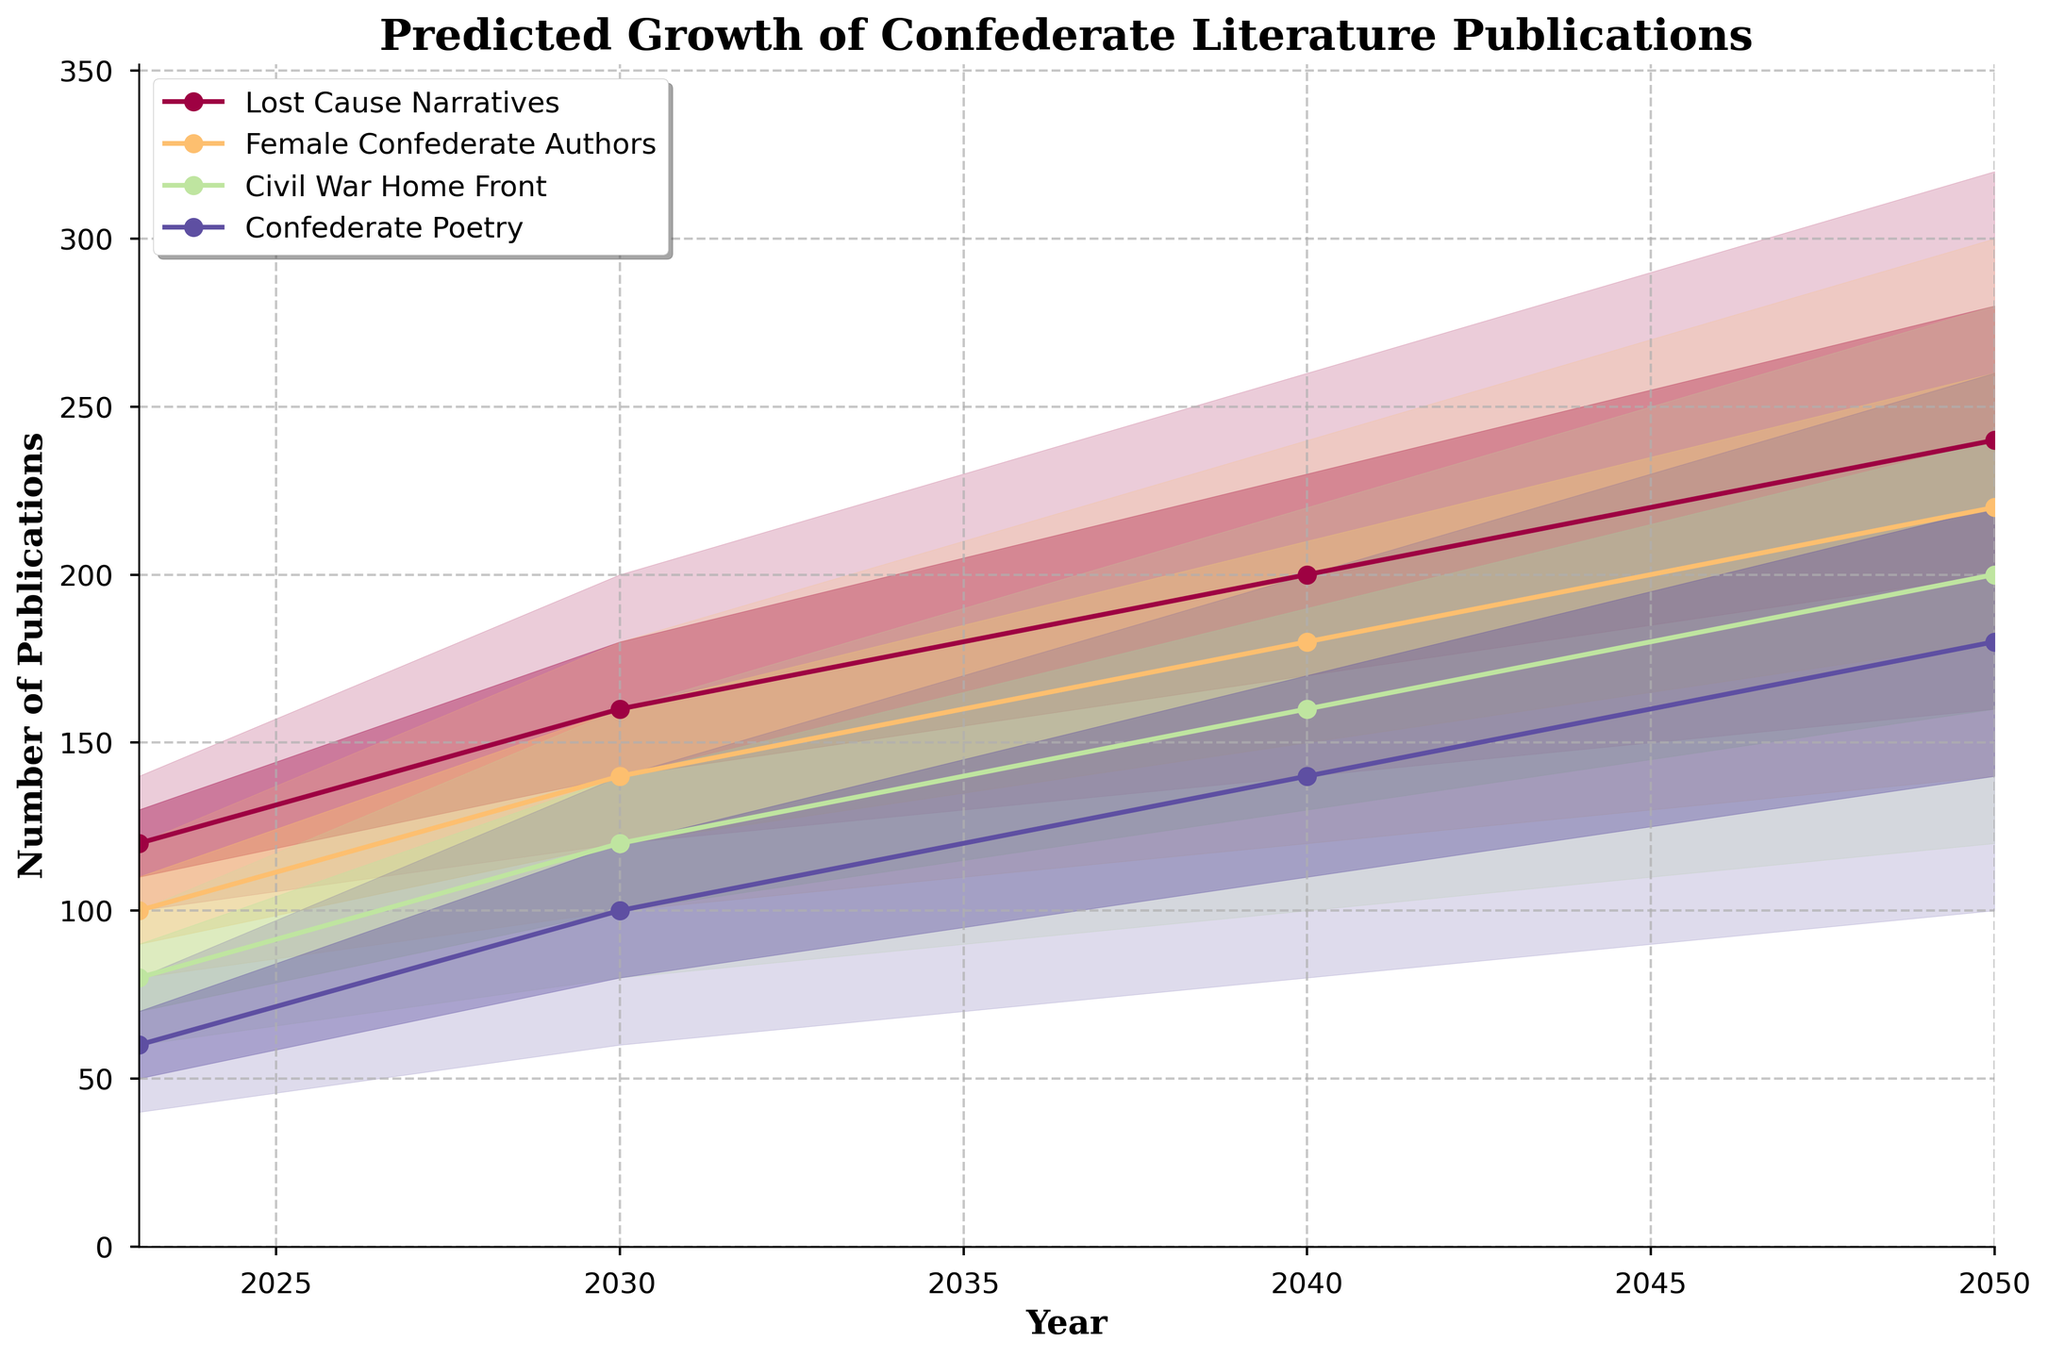What is the title of the figure? The title of the figure is displayed at the top, in bold and serif font style. To find it, one simply needs to look at the top of the chart.
Answer: "Predicted Growth of Confederate Literature Publications" What year does the chart predict the number of publications for? The x-axis of the chart represents the year, showing the range of predictions. The endpoints of this range can be found on the leftmost and rightmost points of the x-axis.
Answer: 2023 to 2050 Which topic shows the highest number of publications in 2050 according to the median prediction? Locate the data points for each topic in the year 2050 along the x-axis and compare their median values, which are the central lines within the shaded areas.
Answer: Lost Cause Narratives What is the predicted median number of publications for Female Confederate Authors in 2040? Find the topic 'Female Confederate Authors' and follow its median line to the year 2040 on the x-axis. The value where it intersects the vertical line for 2040 is the answer.
Answer: 180 What is the range of predicted publications for Confederate Poetry in 2030? For the topic 'Confederate Poetry' in the year 2030, the range is determined by the lower and upper bounds of the shaded area. Identify these values from the filled regions in the chart.
Answer: 60 to 140 Compare the median predicted publications for Civil War Home Front and Female Confederate Authors in 2023. Which is higher? Find the median values for both topics in the year 2023 and compare them.
Answer: Female Confederate Authors How many topics are represented in the chart? Count the unique topics listed in the legend or identified by different colors and labels in the chart.
Answer: 4 In which year is the predicted median number of publications for Lost Cause Narratives closest to 200? Follow the median line for 'Lost Cause Narratives' and check where it approximately intersects the value of 200 on the y-axis across different years.
Answer: 2040 What is the average range (Upper Bound - Lower Bound) of predicted publications for the topic Female Confederate Authors across all years? For each year, calculate the difference between the upper and lower bounds, sum these differences, and then divide by the number of years.
Answer: (40+60+90+140)/4 = 82.5 